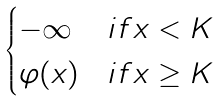<formula> <loc_0><loc_0><loc_500><loc_500>\begin{cases} - \infty & i f x < K \\ \varphi ( x ) & i f x \geq K \end{cases}</formula> 